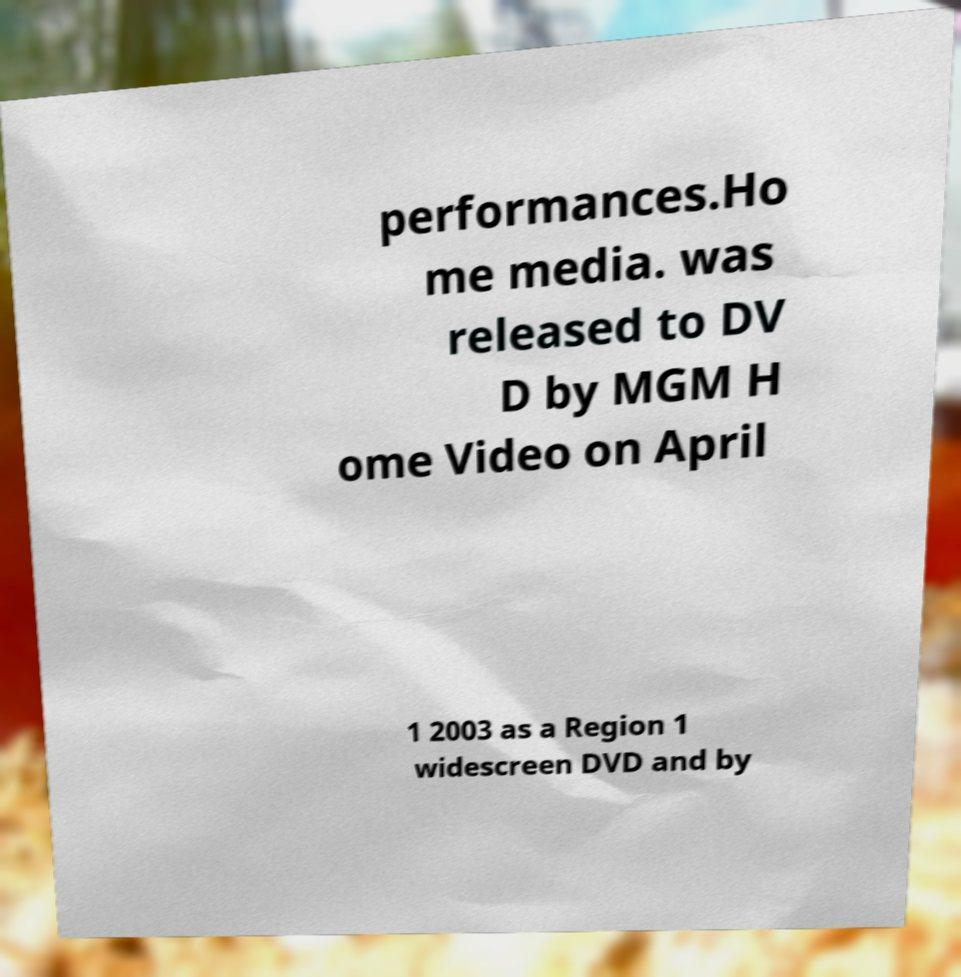Could you assist in decoding the text presented in this image and type it out clearly? performances.Ho me media. was released to DV D by MGM H ome Video on April 1 2003 as a Region 1 widescreen DVD and by 